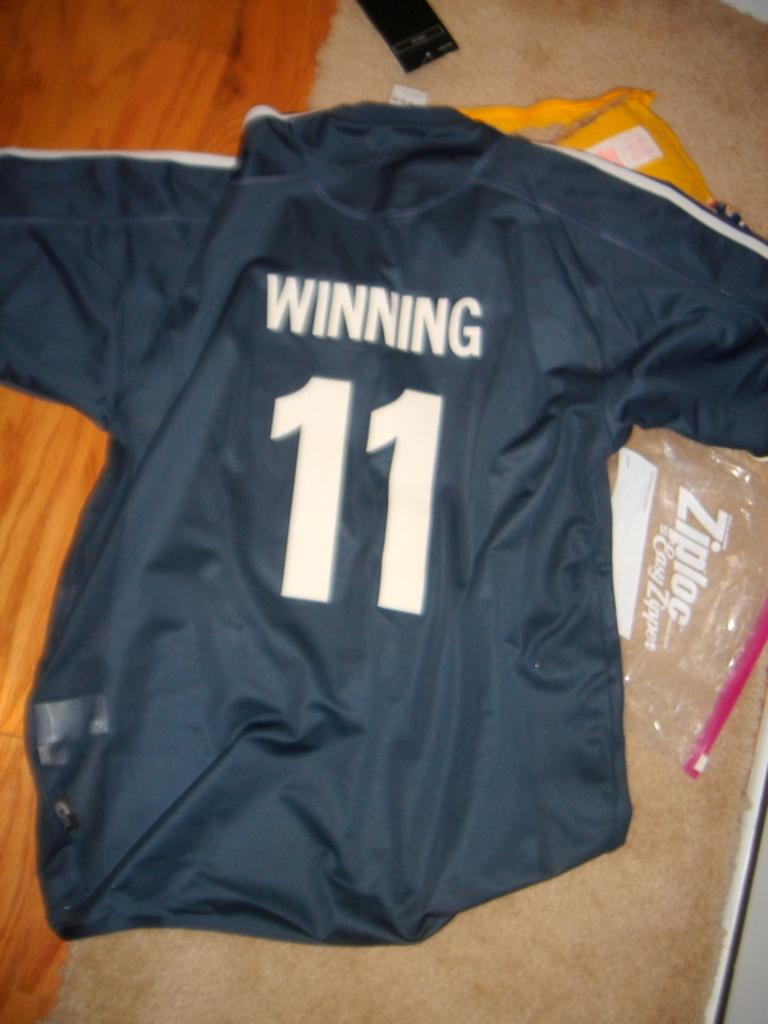<image>
Give a short and clear explanation of the subsequent image. A blue jersey with Winning 11 on the back. 